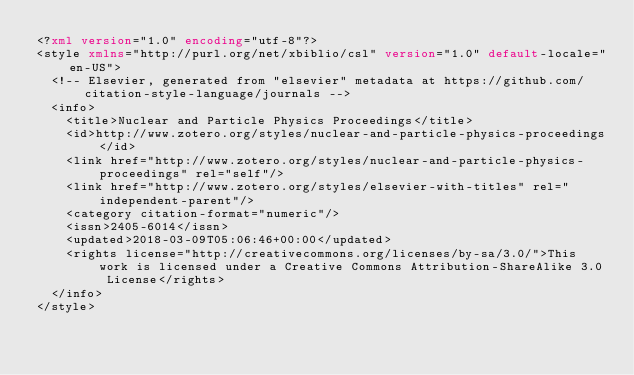Convert code to text. <code><loc_0><loc_0><loc_500><loc_500><_XML_><?xml version="1.0" encoding="utf-8"?>
<style xmlns="http://purl.org/net/xbiblio/csl" version="1.0" default-locale="en-US">
  <!-- Elsevier, generated from "elsevier" metadata at https://github.com/citation-style-language/journals -->
  <info>
    <title>Nuclear and Particle Physics Proceedings</title>
    <id>http://www.zotero.org/styles/nuclear-and-particle-physics-proceedings</id>
    <link href="http://www.zotero.org/styles/nuclear-and-particle-physics-proceedings" rel="self"/>
    <link href="http://www.zotero.org/styles/elsevier-with-titles" rel="independent-parent"/>
    <category citation-format="numeric"/>
    <issn>2405-6014</issn>
    <updated>2018-03-09T05:06:46+00:00</updated>
    <rights license="http://creativecommons.org/licenses/by-sa/3.0/">This work is licensed under a Creative Commons Attribution-ShareAlike 3.0 License</rights>
  </info>
</style>
</code> 